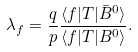Convert formula to latex. <formula><loc_0><loc_0><loc_500><loc_500>\lambda _ { f } = \frac { q } { p } \frac { \langle f | T | \bar { B } ^ { 0 } \rangle } { \langle f | T | B ^ { 0 } \rangle } .</formula> 